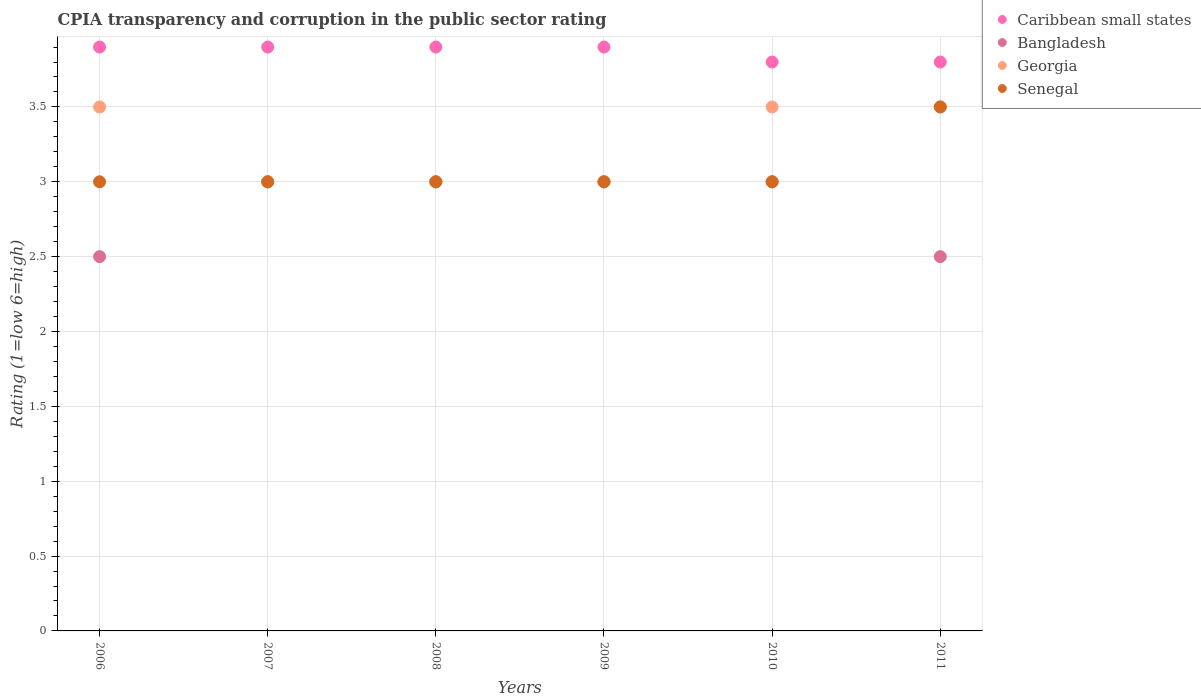How many different coloured dotlines are there?
Your answer should be very brief. 4. Is the number of dotlines equal to the number of legend labels?
Ensure brevity in your answer.  Yes. Across all years, what is the maximum CPIA rating in Georgia?
Give a very brief answer. 3.5. Across all years, what is the minimum CPIA rating in Caribbean small states?
Provide a short and direct response. 3.8. In which year was the CPIA rating in Bangladesh maximum?
Make the answer very short. 2007. In which year was the CPIA rating in Georgia minimum?
Keep it short and to the point. 2007. What is the total CPIA rating in Caribbean small states in the graph?
Make the answer very short. 23.2. What is the difference between the CPIA rating in Caribbean small states in 2007 and that in 2011?
Your answer should be compact. 0.1. What is the difference between the CPIA rating in Senegal in 2007 and the CPIA rating in Georgia in 2010?
Your answer should be very brief. -0.5. What is the average CPIA rating in Senegal per year?
Your answer should be compact. 3.08. What is the ratio of the CPIA rating in Bangladesh in 2006 to that in 2010?
Ensure brevity in your answer.  0.83. What is the difference between the highest and the second highest CPIA rating in Bangladesh?
Ensure brevity in your answer.  0. What is the difference between the highest and the lowest CPIA rating in Caribbean small states?
Keep it short and to the point. 0.1. In how many years, is the CPIA rating in Caribbean small states greater than the average CPIA rating in Caribbean small states taken over all years?
Make the answer very short. 4. Is the CPIA rating in Caribbean small states strictly greater than the CPIA rating in Georgia over the years?
Provide a succinct answer. Yes. How many dotlines are there?
Offer a terse response. 4. How many years are there in the graph?
Make the answer very short. 6. Are the values on the major ticks of Y-axis written in scientific E-notation?
Your response must be concise. No. Does the graph contain grids?
Ensure brevity in your answer.  Yes. Where does the legend appear in the graph?
Offer a terse response. Top right. How many legend labels are there?
Your answer should be compact. 4. How are the legend labels stacked?
Offer a terse response. Vertical. What is the title of the graph?
Offer a terse response. CPIA transparency and corruption in the public sector rating. Does "Liechtenstein" appear as one of the legend labels in the graph?
Provide a short and direct response. No. What is the label or title of the X-axis?
Offer a very short reply. Years. What is the Rating (1=low 6=high) of Caribbean small states in 2006?
Your response must be concise. 3.9. What is the Rating (1=low 6=high) in Georgia in 2006?
Provide a short and direct response. 3.5. What is the Rating (1=low 6=high) of Georgia in 2007?
Your answer should be very brief. 3. What is the Rating (1=low 6=high) of Caribbean small states in 2008?
Your answer should be compact. 3.9. What is the Rating (1=low 6=high) in Bangladesh in 2008?
Provide a succinct answer. 3. What is the Rating (1=low 6=high) of Georgia in 2008?
Offer a terse response. 3. What is the Rating (1=low 6=high) in Caribbean small states in 2010?
Keep it short and to the point. 3.8. What is the Rating (1=low 6=high) in Bangladesh in 2011?
Provide a short and direct response. 2.5. What is the Rating (1=low 6=high) of Georgia in 2011?
Your answer should be very brief. 3.5. Across all years, what is the minimum Rating (1=low 6=high) of Georgia?
Offer a very short reply. 3. Across all years, what is the minimum Rating (1=low 6=high) of Senegal?
Offer a terse response. 3. What is the total Rating (1=low 6=high) in Caribbean small states in the graph?
Your answer should be compact. 23.2. What is the total Rating (1=low 6=high) of Bangladesh in the graph?
Offer a terse response. 17. What is the difference between the Rating (1=low 6=high) of Bangladesh in 2006 and that in 2007?
Provide a succinct answer. -0.5. What is the difference between the Rating (1=low 6=high) in Georgia in 2006 and that in 2007?
Your response must be concise. 0.5. What is the difference between the Rating (1=low 6=high) of Bangladesh in 2006 and that in 2008?
Offer a terse response. -0.5. What is the difference between the Rating (1=low 6=high) of Georgia in 2006 and that in 2008?
Your answer should be compact. 0.5. What is the difference between the Rating (1=low 6=high) of Bangladesh in 2006 and that in 2009?
Offer a terse response. -0.5. What is the difference between the Rating (1=low 6=high) of Bangladesh in 2006 and that in 2010?
Keep it short and to the point. -0.5. What is the difference between the Rating (1=low 6=high) in Georgia in 2006 and that in 2010?
Give a very brief answer. 0. What is the difference between the Rating (1=low 6=high) of Senegal in 2006 and that in 2010?
Keep it short and to the point. 0. What is the difference between the Rating (1=low 6=high) of Caribbean small states in 2007 and that in 2009?
Give a very brief answer. 0. What is the difference between the Rating (1=low 6=high) of Bangladesh in 2007 and that in 2009?
Your answer should be compact. 0. What is the difference between the Rating (1=low 6=high) in Caribbean small states in 2007 and that in 2010?
Provide a succinct answer. 0.1. What is the difference between the Rating (1=low 6=high) in Georgia in 2007 and that in 2010?
Give a very brief answer. -0.5. What is the difference between the Rating (1=low 6=high) of Senegal in 2007 and that in 2010?
Provide a short and direct response. 0. What is the difference between the Rating (1=low 6=high) in Caribbean small states in 2008 and that in 2009?
Your response must be concise. 0. What is the difference between the Rating (1=low 6=high) of Georgia in 2008 and that in 2009?
Make the answer very short. 0. What is the difference between the Rating (1=low 6=high) of Senegal in 2008 and that in 2009?
Provide a short and direct response. 0. What is the difference between the Rating (1=low 6=high) of Bangladesh in 2008 and that in 2010?
Ensure brevity in your answer.  0. What is the difference between the Rating (1=low 6=high) in Senegal in 2008 and that in 2010?
Your response must be concise. 0. What is the difference between the Rating (1=low 6=high) of Caribbean small states in 2008 and that in 2011?
Ensure brevity in your answer.  0.1. What is the difference between the Rating (1=low 6=high) of Bangladesh in 2008 and that in 2011?
Offer a very short reply. 0.5. What is the difference between the Rating (1=low 6=high) in Caribbean small states in 2009 and that in 2010?
Keep it short and to the point. 0.1. What is the difference between the Rating (1=low 6=high) of Bangladesh in 2009 and that in 2010?
Make the answer very short. 0. What is the difference between the Rating (1=low 6=high) in Caribbean small states in 2009 and that in 2011?
Make the answer very short. 0.1. What is the difference between the Rating (1=low 6=high) of Bangladesh in 2010 and that in 2011?
Keep it short and to the point. 0.5. What is the difference between the Rating (1=low 6=high) in Georgia in 2010 and that in 2011?
Give a very brief answer. 0. What is the difference between the Rating (1=low 6=high) of Senegal in 2010 and that in 2011?
Provide a short and direct response. -0.5. What is the difference between the Rating (1=low 6=high) in Georgia in 2006 and the Rating (1=low 6=high) in Senegal in 2007?
Offer a very short reply. 0.5. What is the difference between the Rating (1=low 6=high) of Caribbean small states in 2006 and the Rating (1=low 6=high) of Bangladesh in 2008?
Keep it short and to the point. 0.9. What is the difference between the Rating (1=low 6=high) of Caribbean small states in 2006 and the Rating (1=low 6=high) of Georgia in 2008?
Make the answer very short. 0.9. What is the difference between the Rating (1=low 6=high) in Caribbean small states in 2006 and the Rating (1=low 6=high) in Senegal in 2008?
Your response must be concise. 0.9. What is the difference between the Rating (1=low 6=high) of Bangladesh in 2006 and the Rating (1=low 6=high) of Senegal in 2008?
Give a very brief answer. -0.5. What is the difference between the Rating (1=low 6=high) of Georgia in 2006 and the Rating (1=low 6=high) of Senegal in 2008?
Give a very brief answer. 0.5. What is the difference between the Rating (1=low 6=high) of Georgia in 2006 and the Rating (1=low 6=high) of Senegal in 2009?
Your answer should be compact. 0.5. What is the difference between the Rating (1=low 6=high) in Caribbean small states in 2006 and the Rating (1=low 6=high) in Georgia in 2010?
Keep it short and to the point. 0.4. What is the difference between the Rating (1=low 6=high) of Bangladesh in 2006 and the Rating (1=low 6=high) of Georgia in 2010?
Ensure brevity in your answer.  -1. What is the difference between the Rating (1=low 6=high) of Bangladesh in 2006 and the Rating (1=low 6=high) of Senegal in 2010?
Your answer should be compact. -0.5. What is the difference between the Rating (1=low 6=high) in Caribbean small states in 2006 and the Rating (1=low 6=high) in Georgia in 2011?
Your response must be concise. 0.4. What is the difference between the Rating (1=low 6=high) in Caribbean small states in 2006 and the Rating (1=low 6=high) in Senegal in 2011?
Your response must be concise. 0.4. What is the difference between the Rating (1=low 6=high) of Bangladesh in 2006 and the Rating (1=low 6=high) of Senegal in 2011?
Your answer should be compact. -1. What is the difference between the Rating (1=low 6=high) in Caribbean small states in 2007 and the Rating (1=low 6=high) in Georgia in 2008?
Make the answer very short. 0.9. What is the difference between the Rating (1=low 6=high) in Caribbean small states in 2007 and the Rating (1=low 6=high) in Bangladesh in 2009?
Give a very brief answer. 0.9. What is the difference between the Rating (1=low 6=high) in Caribbean small states in 2007 and the Rating (1=low 6=high) in Georgia in 2009?
Make the answer very short. 0.9. What is the difference between the Rating (1=low 6=high) of Bangladesh in 2007 and the Rating (1=low 6=high) of Senegal in 2009?
Your answer should be compact. 0. What is the difference between the Rating (1=low 6=high) in Georgia in 2007 and the Rating (1=low 6=high) in Senegal in 2009?
Your answer should be very brief. 0. What is the difference between the Rating (1=low 6=high) in Caribbean small states in 2007 and the Rating (1=low 6=high) in Bangladesh in 2010?
Offer a terse response. 0.9. What is the difference between the Rating (1=low 6=high) of Caribbean small states in 2007 and the Rating (1=low 6=high) of Georgia in 2010?
Your response must be concise. 0.4. What is the difference between the Rating (1=low 6=high) of Caribbean small states in 2007 and the Rating (1=low 6=high) of Senegal in 2010?
Make the answer very short. 0.9. What is the difference between the Rating (1=low 6=high) of Bangladesh in 2007 and the Rating (1=low 6=high) of Senegal in 2010?
Your answer should be very brief. 0. What is the difference between the Rating (1=low 6=high) of Georgia in 2007 and the Rating (1=low 6=high) of Senegal in 2010?
Ensure brevity in your answer.  0. What is the difference between the Rating (1=low 6=high) in Caribbean small states in 2007 and the Rating (1=low 6=high) in Bangladesh in 2011?
Ensure brevity in your answer.  1.4. What is the difference between the Rating (1=low 6=high) in Caribbean small states in 2007 and the Rating (1=low 6=high) in Georgia in 2011?
Your response must be concise. 0.4. What is the difference between the Rating (1=low 6=high) in Caribbean small states in 2007 and the Rating (1=low 6=high) in Senegal in 2011?
Provide a succinct answer. 0.4. What is the difference between the Rating (1=low 6=high) in Bangladesh in 2007 and the Rating (1=low 6=high) in Georgia in 2011?
Offer a terse response. -0.5. What is the difference between the Rating (1=low 6=high) of Caribbean small states in 2008 and the Rating (1=low 6=high) of Georgia in 2009?
Provide a succinct answer. 0.9. What is the difference between the Rating (1=low 6=high) of Caribbean small states in 2008 and the Rating (1=low 6=high) of Senegal in 2009?
Offer a terse response. 0.9. What is the difference between the Rating (1=low 6=high) of Georgia in 2008 and the Rating (1=low 6=high) of Senegal in 2009?
Give a very brief answer. 0. What is the difference between the Rating (1=low 6=high) in Bangladesh in 2008 and the Rating (1=low 6=high) in Georgia in 2010?
Ensure brevity in your answer.  -0.5. What is the difference between the Rating (1=low 6=high) of Bangladesh in 2008 and the Rating (1=low 6=high) of Senegal in 2010?
Provide a short and direct response. 0. What is the difference between the Rating (1=low 6=high) of Georgia in 2008 and the Rating (1=low 6=high) of Senegal in 2010?
Your response must be concise. 0. What is the difference between the Rating (1=low 6=high) of Georgia in 2008 and the Rating (1=low 6=high) of Senegal in 2011?
Your answer should be very brief. -0.5. What is the difference between the Rating (1=low 6=high) in Caribbean small states in 2009 and the Rating (1=low 6=high) in Bangladesh in 2010?
Give a very brief answer. 0.9. What is the difference between the Rating (1=low 6=high) in Bangladesh in 2009 and the Rating (1=low 6=high) in Georgia in 2010?
Make the answer very short. -0.5. What is the difference between the Rating (1=low 6=high) in Georgia in 2009 and the Rating (1=low 6=high) in Senegal in 2010?
Provide a short and direct response. 0. What is the difference between the Rating (1=low 6=high) of Caribbean small states in 2009 and the Rating (1=low 6=high) of Georgia in 2011?
Offer a terse response. 0.4. What is the difference between the Rating (1=low 6=high) of Bangladesh in 2009 and the Rating (1=low 6=high) of Georgia in 2011?
Your answer should be very brief. -0.5. What is the difference between the Rating (1=low 6=high) in Bangladesh in 2009 and the Rating (1=low 6=high) in Senegal in 2011?
Your answer should be very brief. -0.5. What is the difference between the Rating (1=low 6=high) in Georgia in 2009 and the Rating (1=low 6=high) in Senegal in 2011?
Give a very brief answer. -0.5. What is the difference between the Rating (1=low 6=high) of Caribbean small states in 2010 and the Rating (1=low 6=high) of Bangladesh in 2011?
Your response must be concise. 1.3. What is the difference between the Rating (1=low 6=high) of Caribbean small states in 2010 and the Rating (1=low 6=high) of Georgia in 2011?
Offer a terse response. 0.3. What is the difference between the Rating (1=low 6=high) of Caribbean small states in 2010 and the Rating (1=low 6=high) of Senegal in 2011?
Provide a short and direct response. 0.3. What is the difference between the Rating (1=low 6=high) of Bangladesh in 2010 and the Rating (1=low 6=high) of Georgia in 2011?
Keep it short and to the point. -0.5. What is the difference between the Rating (1=low 6=high) of Bangladesh in 2010 and the Rating (1=low 6=high) of Senegal in 2011?
Offer a terse response. -0.5. What is the difference between the Rating (1=low 6=high) of Georgia in 2010 and the Rating (1=low 6=high) of Senegal in 2011?
Your answer should be compact. 0. What is the average Rating (1=low 6=high) of Caribbean small states per year?
Provide a short and direct response. 3.87. What is the average Rating (1=low 6=high) of Bangladesh per year?
Give a very brief answer. 2.83. What is the average Rating (1=low 6=high) of Georgia per year?
Make the answer very short. 3.25. What is the average Rating (1=low 6=high) in Senegal per year?
Your answer should be compact. 3.08. In the year 2006, what is the difference between the Rating (1=low 6=high) in Caribbean small states and Rating (1=low 6=high) in Georgia?
Provide a short and direct response. 0.4. In the year 2006, what is the difference between the Rating (1=low 6=high) of Caribbean small states and Rating (1=low 6=high) of Senegal?
Your answer should be compact. 0.9. In the year 2007, what is the difference between the Rating (1=low 6=high) in Caribbean small states and Rating (1=low 6=high) in Georgia?
Provide a short and direct response. 0.9. In the year 2008, what is the difference between the Rating (1=low 6=high) of Caribbean small states and Rating (1=low 6=high) of Bangladesh?
Make the answer very short. 0.9. In the year 2008, what is the difference between the Rating (1=low 6=high) in Caribbean small states and Rating (1=low 6=high) in Senegal?
Your answer should be very brief. 0.9. In the year 2008, what is the difference between the Rating (1=low 6=high) in Bangladesh and Rating (1=low 6=high) in Senegal?
Ensure brevity in your answer.  0. In the year 2009, what is the difference between the Rating (1=low 6=high) of Caribbean small states and Rating (1=low 6=high) of Bangladesh?
Provide a succinct answer. 0.9. In the year 2009, what is the difference between the Rating (1=low 6=high) of Caribbean small states and Rating (1=low 6=high) of Georgia?
Offer a terse response. 0.9. In the year 2009, what is the difference between the Rating (1=low 6=high) in Caribbean small states and Rating (1=low 6=high) in Senegal?
Your answer should be very brief. 0.9. In the year 2009, what is the difference between the Rating (1=low 6=high) of Bangladesh and Rating (1=low 6=high) of Georgia?
Offer a very short reply. 0. In the year 2009, what is the difference between the Rating (1=low 6=high) in Bangladesh and Rating (1=low 6=high) in Senegal?
Provide a succinct answer. 0. In the year 2009, what is the difference between the Rating (1=low 6=high) of Georgia and Rating (1=low 6=high) of Senegal?
Provide a short and direct response. 0. In the year 2010, what is the difference between the Rating (1=low 6=high) of Caribbean small states and Rating (1=low 6=high) of Georgia?
Your answer should be compact. 0.3. In the year 2010, what is the difference between the Rating (1=low 6=high) in Bangladesh and Rating (1=low 6=high) in Georgia?
Your answer should be compact. -0.5. In the year 2010, what is the difference between the Rating (1=low 6=high) in Georgia and Rating (1=low 6=high) in Senegal?
Your answer should be compact. 0.5. In the year 2011, what is the difference between the Rating (1=low 6=high) of Caribbean small states and Rating (1=low 6=high) of Bangladesh?
Your response must be concise. 1.3. In the year 2011, what is the difference between the Rating (1=low 6=high) of Caribbean small states and Rating (1=low 6=high) of Senegal?
Your answer should be very brief. 0.3. What is the ratio of the Rating (1=low 6=high) of Caribbean small states in 2006 to that in 2007?
Your response must be concise. 1. What is the ratio of the Rating (1=low 6=high) of Bangladesh in 2006 to that in 2007?
Make the answer very short. 0.83. What is the ratio of the Rating (1=low 6=high) in Georgia in 2006 to that in 2007?
Make the answer very short. 1.17. What is the ratio of the Rating (1=low 6=high) of Bangladesh in 2006 to that in 2008?
Offer a terse response. 0.83. What is the ratio of the Rating (1=low 6=high) in Georgia in 2006 to that in 2008?
Keep it short and to the point. 1.17. What is the ratio of the Rating (1=low 6=high) of Senegal in 2006 to that in 2008?
Offer a terse response. 1. What is the ratio of the Rating (1=low 6=high) in Caribbean small states in 2006 to that in 2009?
Offer a very short reply. 1. What is the ratio of the Rating (1=low 6=high) in Bangladesh in 2006 to that in 2009?
Provide a short and direct response. 0.83. What is the ratio of the Rating (1=low 6=high) of Senegal in 2006 to that in 2009?
Provide a succinct answer. 1. What is the ratio of the Rating (1=low 6=high) of Caribbean small states in 2006 to that in 2010?
Your answer should be compact. 1.03. What is the ratio of the Rating (1=low 6=high) of Bangladesh in 2006 to that in 2010?
Provide a succinct answer. 0.83. What is the ratio of the Rating (1=low 6=high) of Georgia in 2006 to that in 2010?
Provide a short and direct response. 1. What is the ratio of the Rating (1=low 6=high) in Senegal in 2006 to that in 2010?
Offer a very short reply. 1. What is the ratio of the Rating (1=low 6=high) in Caribbean small states in 2006 to that in 2011?
Your answer should be compact. 1.03. What is the ratio of the Rating (1=low 6=high) of Bangladesh in 2006 to that in 2011?
Offer a very short reply. 1. What is the ratio of the Rating (1=low 6=high) in Georgia in 2006 to that in 2011?
Your answer should be very brief. 1. What is the ratio of the Rating (1=low 6=high) of Senegal in 2006 to that in 2011?
Your answer should be very brief. 0.86. What is the ratio of the Rating (1=low 6=high) of Caribbean small states in 2007 to that in 2008?
Your answer should be very brief. 1. What is the ratio of the Rating (1=low 6=high) of Georgia in 2007 to that in 2008?
Offer a very short reply. 1. What is the ratio of the Rating (1=low 6=high) of Senegal in 2007 to that in 2008?
Your answer should be very brief. 1. What is the ratio of the Rating (1=low 6=high) in Bangladesh in 2007 to that in 2009?
Your answer should be compact. 1. What is the ratio of the Rating (1=low 6=high) in Georgia in 2007 to that in 2009?
Your answer should be very brief. 1. What is the ratio of the Rating (1=low 6=high) in Senegal in 2007 to that in 2009?
Ensure brevity in your answer.  1. What is the ratio of the Rating (1=low 6=high) of Caribbean small states in 2007 to that in 2010?
Offer a very short reply. 1.03. What is the ratio of the Rating (1=low 6=high) in Senegal in 2007 to that in 2010?
Keep it short and to the point. 1. What is the ratio of the Rating (1=low 6=high) of Caribbean small states in 2007 to that in 2011?
Keep it short and to the point. 1.03. What is the ratio of the Rating (1=low 6=high) of Bangladesh in 2007 to that in 2011?
Ensure brevity in your answer.  1.2. What is the ratio of the Rating (1=low 6=high) in Caribbean small states in 2008 to that in 2009?
Provide a short and direct response. 1. What is the ratio of the Rating (1=low 6=high) of Caribbean small states in 2008 to that in 2010?
Make the answer very short. 1.03. What is the ratio of the Rating (1=low 6=high) of Georgia in 2008 to that in 2010?
Make the answer very short. 0.86. What is the ratio of the Rating (1=low 6=high) in Caribbean small states in 2008 to that in 2011?
Offer a terse response. 1.03. What is the ratio of the Rating (1=low 6=high) in Bangladesh in 2008 to that in 2011?
Ensure brevity in your answer.  1.2. What is the ratio of the Rating (1=low 6=high) in Senegal in 2008 to that in 2011?
Keep it short and to the point. 0.86. What is the ratio of the Rating (1=low 6=high) in Caribbean small states in 2009 to that in 2010?
Keep it short and to the point. 1.03. What is the ratio of the Rating (1=low 6=high) of Bangladesh in 2009 to that in 2010?
Offer a terse response. 1. What is the ratio of the Rating (1=low 6=high) of Georgia in 2009 to that in 2010?
Offer a terse response. 0.86. What is the ratio of the Rating (1=low 6=high) of Caribbean small states in 2009 to that in 2011?
Make the answer very short. 1.03. What is the ratio of the Rating (1=low 6=high) in Senegal in 2009 to that in 2011?
Keep it short and to the point. 0.86. What is the ratio of the Rating (1=low 6=high) of Caribbean small states in 2010 to that in 2011?
Your answer should be very brief. 1. What is the ratio of the Rating (1=low 6=high) of Bangladesh in 2010 to that in 2011?
Provide a succinct answer. 1.2. What is the difference between the highest and the second highest Rating (1=low 6=high) of Georgia?
Keep it short and to the point. 0. What is the difference between the highest and the second highest Rating (1=low 6=high) in Senegal?
Offer a very short reply. 0.5. What is the difference between the highest and the lowest Rating (1=low 6=high) of Bangladesh?
Make the answer very short. 0.5. 